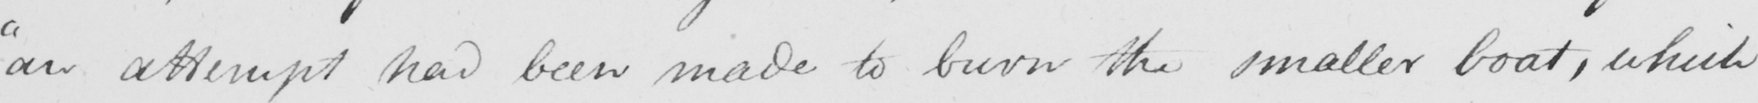What text is written in this handwritten line? " an attempt had been made to burn the smaller boat , which 